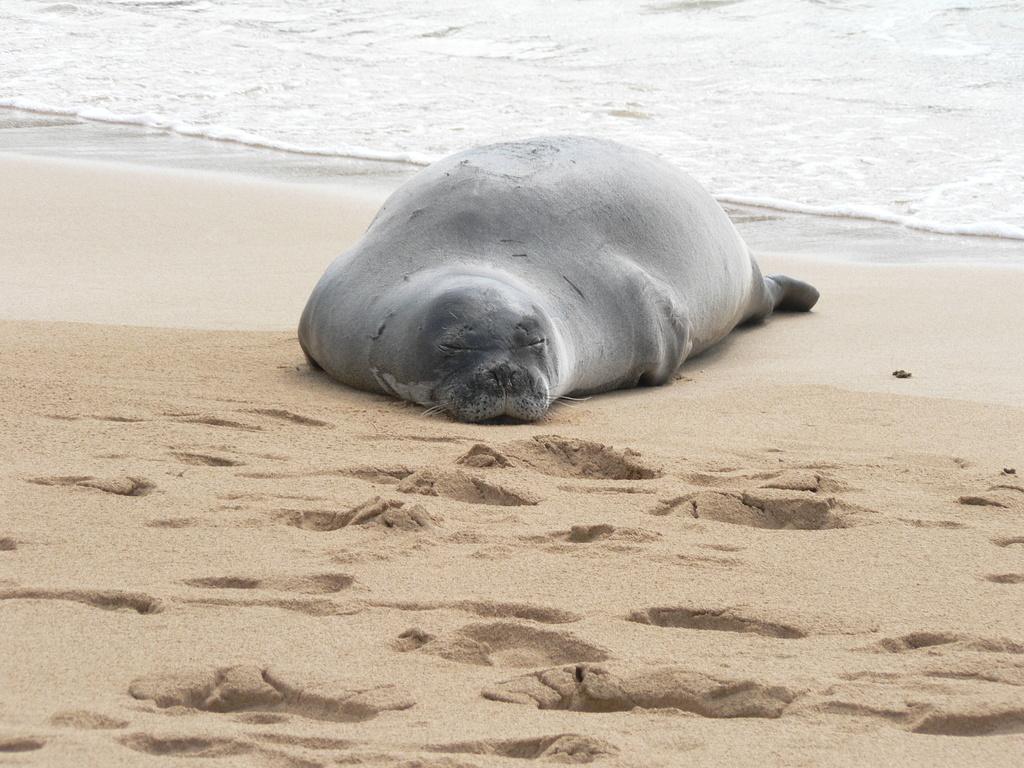Please provide a concise description of this image. In the center of the image we can see a harbor seal. At the top of the image we can see the ocean. In the background of the image we can see the soil. 